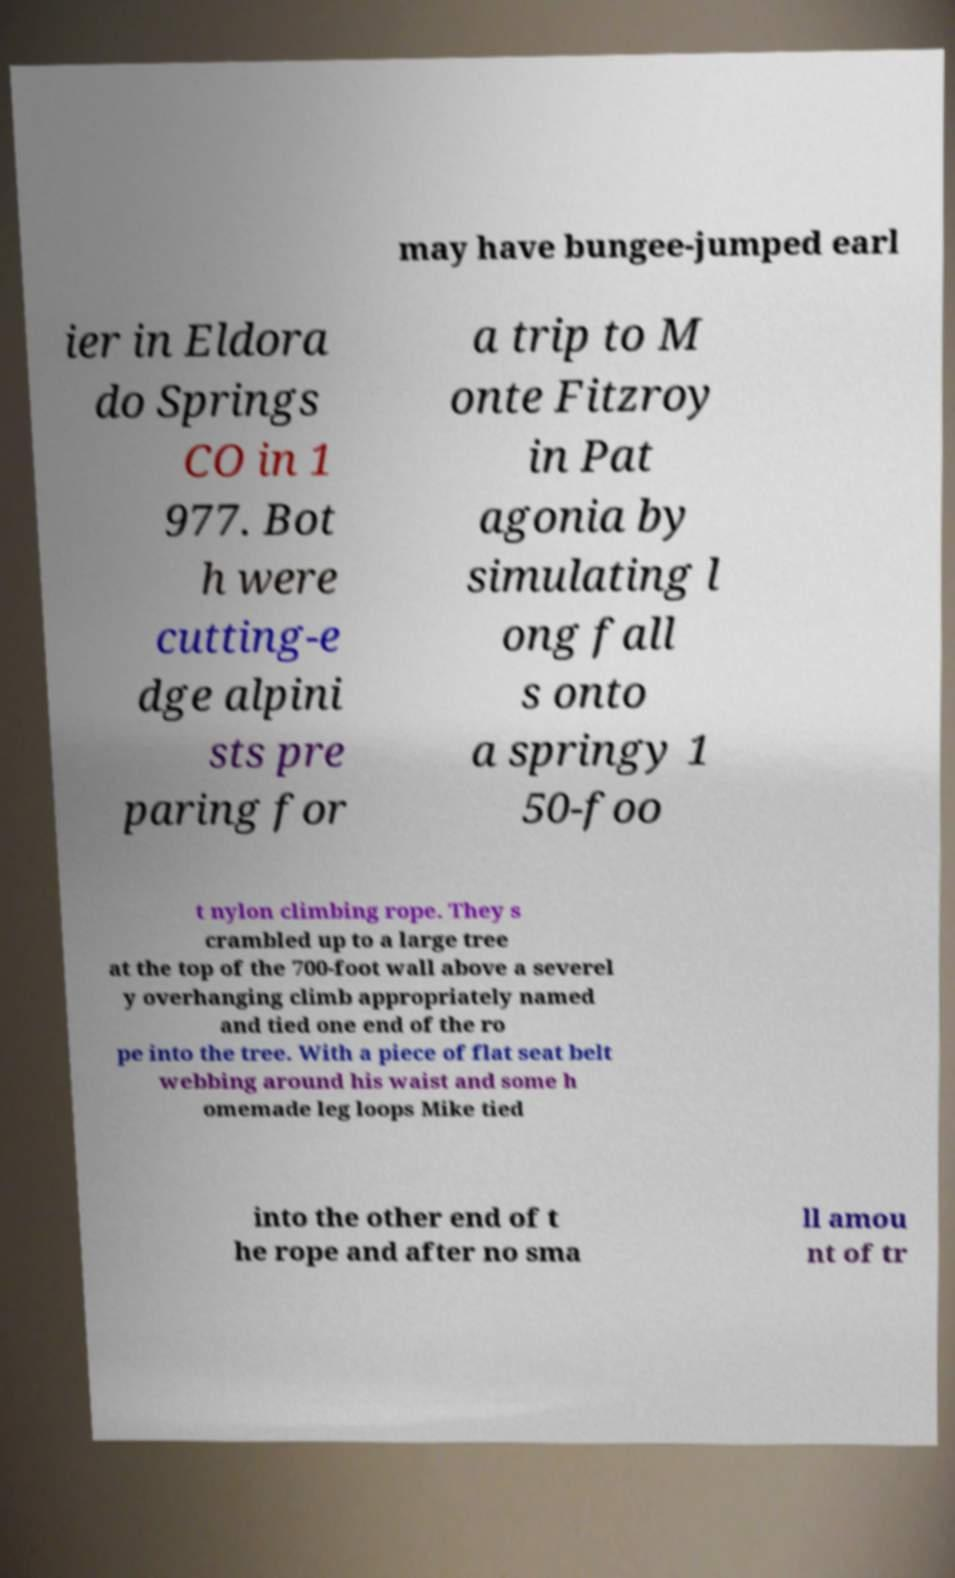I need the written content from this picture converted into text. Can you do that? may have bungee-jumped earl ier in Eldora do Springs CO in 1 977. Bot h were cutting-e dge alpini sts pre paring for a trip to M onte Fitzroy in Pat agonia by simulating l ong fall s onto a springy 1 50-foo t nylon climbing rope. They s crambled up to a large tree at the top of the 700-foot wall above a severel y overhanging climb appropriately named and tied one end of the ro pe into the tree. With a piece of flat seat belt webbing around his waist and some h omemade leg loops Mike tied into the other end of t he rope and after no sma ll amou nt of tr 